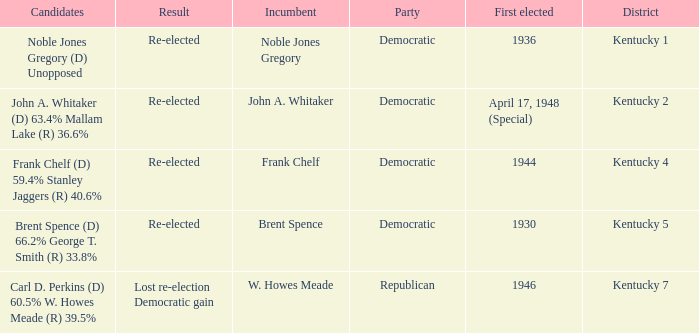List all candidates in the democratic party where the election had the incumbent Frank Chelf running. Frank Chelf (D) 59.4% Stanley Jaggers (R) 40.6%. 